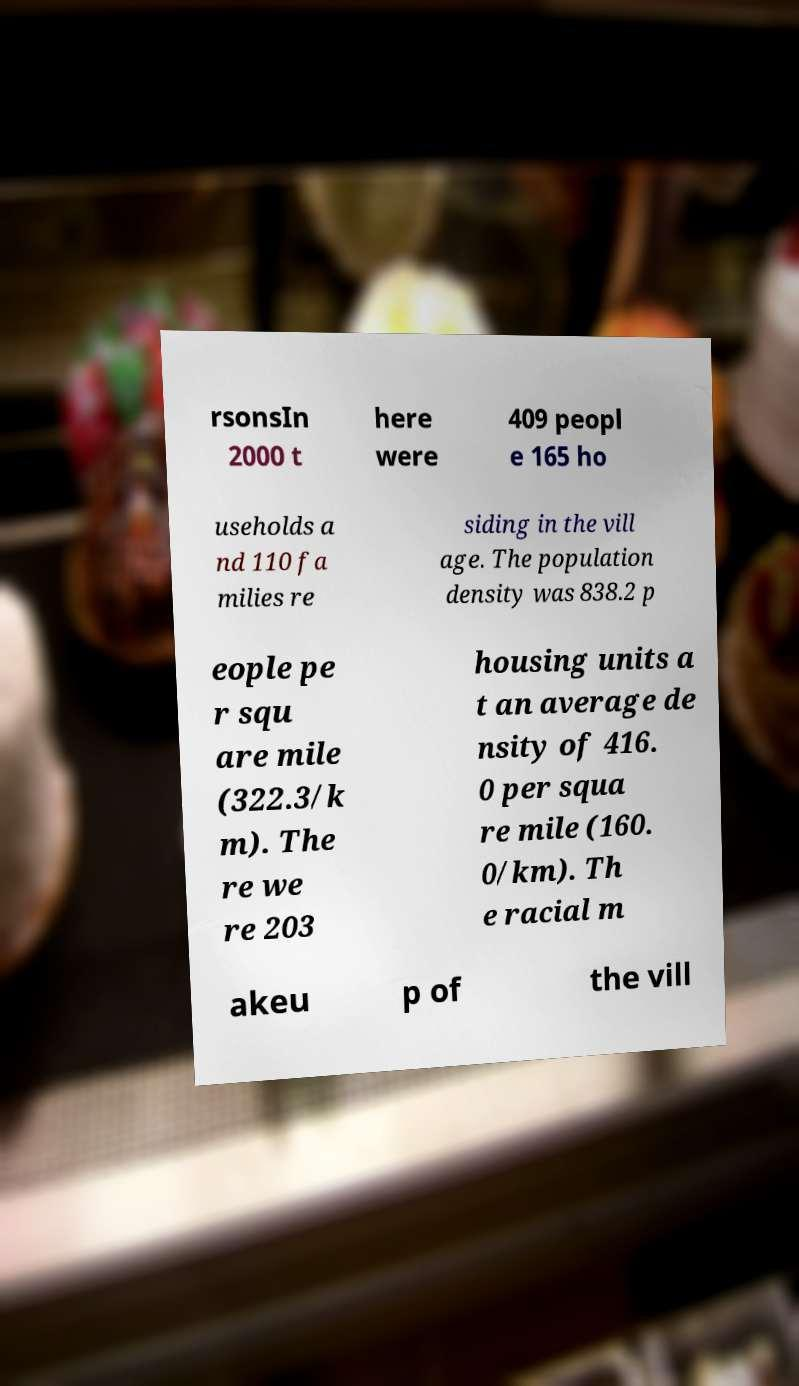I need the written content from this picture converted into text. Can you do that? rsonsIn 2000 t here were 409 peopl e 165 ho useholds a nd 110 fa milies re siding in the vill age. The population density was 838.2 p eople pe r squ are mile (322.3/k m). The re we re 203 housing units a t an average de nsity of 416. 0 per squa re mile (160. 0/km). Th e racial m akeu p of the vill 